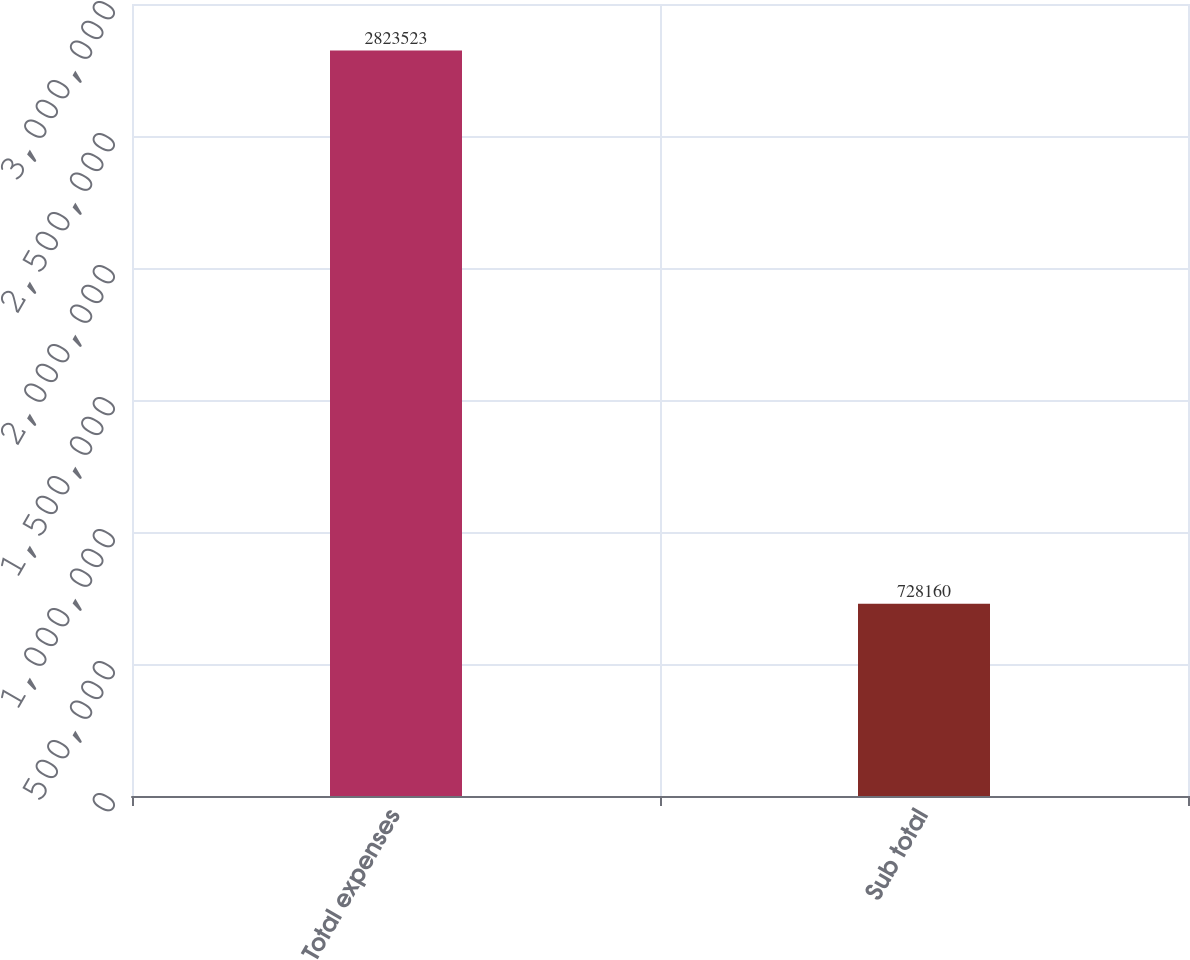<chart> <loc_0><loc_0><loc_500><loc_500><bar_chart><fcel>Total expenses<fcel>Sub total<nl><fcel>2.82352e+06<fcel>728160<nl></chart> 